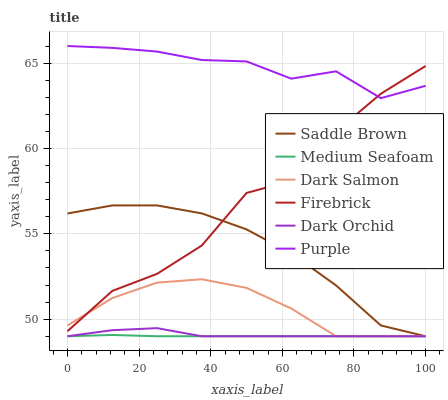Does Medium Seafoam have the minimum area under the curve?
Answer yes or no. Yes. Does Purple have the maximum area under the curve?
Answer yes or no. Yes. Does Firebrick have the minimum area under the curve?
Answer yes or no. No. Does Firebrick have the maximum area under the curve?
Answer yes or no. No. Is Medium Seafoam the smoothest?
Answer yes or no. Yes. Is Firebrick the roughest?
Answer yes or no. Yes. Is Dark Salmon the smoothest?
Answer yes or no. No. Is Dark Salmon the roughest?
Answer yes or no. No. Does Dark Salmon have the lowest value?
Answer yes or no. Yes. Does Firebrick have the lowest value?
Answer yes or no. No. Does Purple have the highest value?
Answer yes or no. Yes. Does Firebrick have the highest value?
Answer yes or no. No. Is Saddle Brown less than Purple?
Answer yes or no. Yes. Is Purple greater than Dark Orchid?
Answer yes or no. Yes. Does Firebrick intersect Saddle Brown?
Answer yes or no. Yes. Is Firebrick less than Saddle Brown?
Answer yes or no. No. Is Firebrick greater than Saddle Brown?
Answer yes or no. No. Does Saddle Brown intersect Purple?
Answer yes or no. No. 